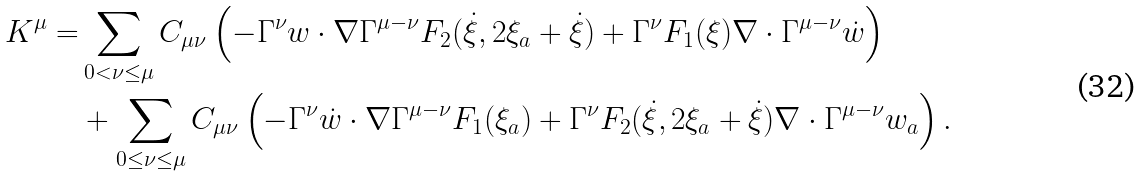<formula> <loc_0><loc_0><loc_500><loc_500>K ^ { \mu } = & \sum _ { 0 < \nu \leq \mu } C _ { \mu \nu } \left ( - \Gamma ^ { \nu } w \cdot \nabla \Gamma ^ { \mu - \nu } F _ { 2 } ( \dot { \xi } , 2 \xi _ { a } + \dot { \xi } ) + \Gamma ^ { \nu } F _ { 1 } ( \xi ) \nabla \cdot \Gamma ^ { \mu - \nu } \dot { w } \right ) \\ & + \sum _ { 0 \leq \nu \leq \mu } C _ { \mu \nu } \left ( - \Gamma ^ { \nu } \dot { w } \cdot \nabla \Gamma ^ { \mu - \nu } F _ { 1 } ( \xi _ { a } ) + \Gamma ^ { \nu } F _ { 2 } ( \dot { \xi } , 2 \xi _ { a } + \dot { \xi } ) \nabla \cdot \Gamma ^ { \mu - \nu } w _ { a } \right ) .</formula> 